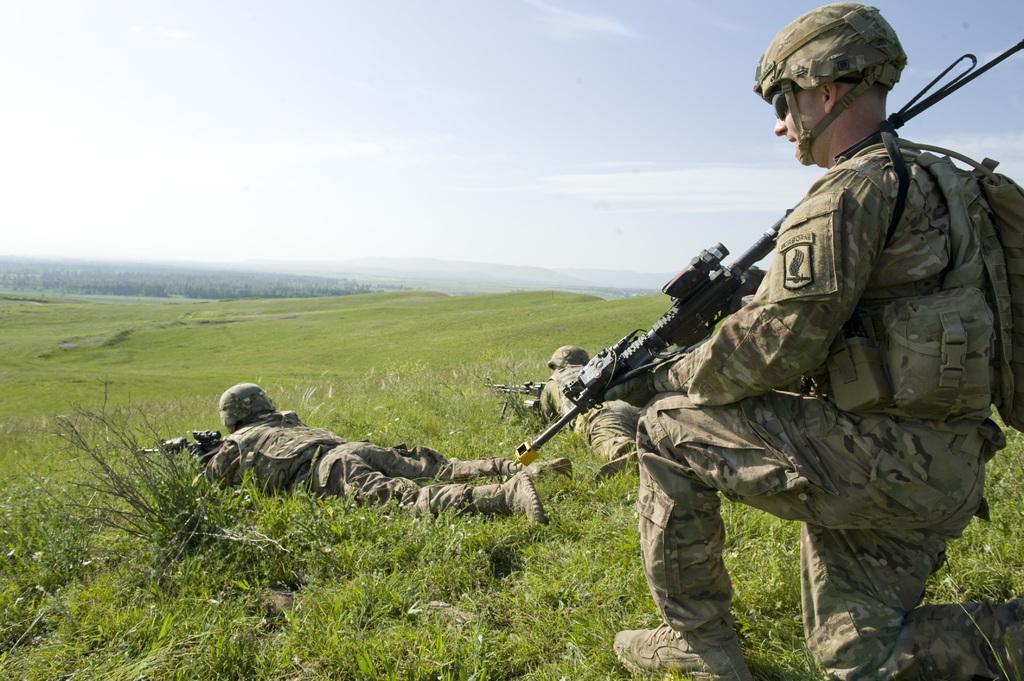Please provide a concise description of this image. In the center of the image we can see persons lying on the grass and holding a guns. On the right side of the image we can see person sitting on the grass holding a gun. In the background we can see trees, plants, grass, sky and clouds. 